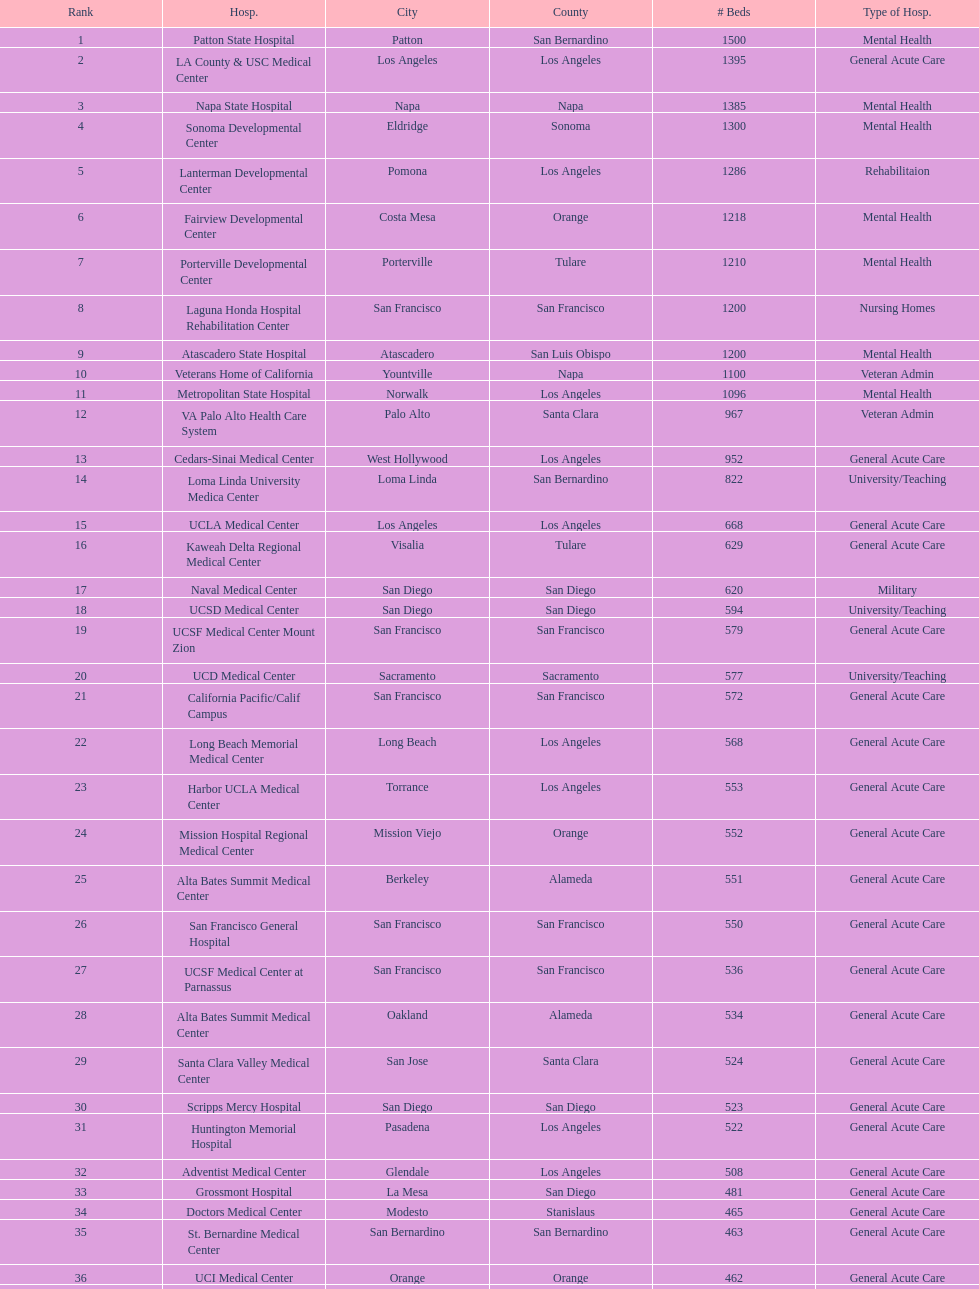How many more general acute care hospitals are there in california than rehabilitation hospitals? 33. 